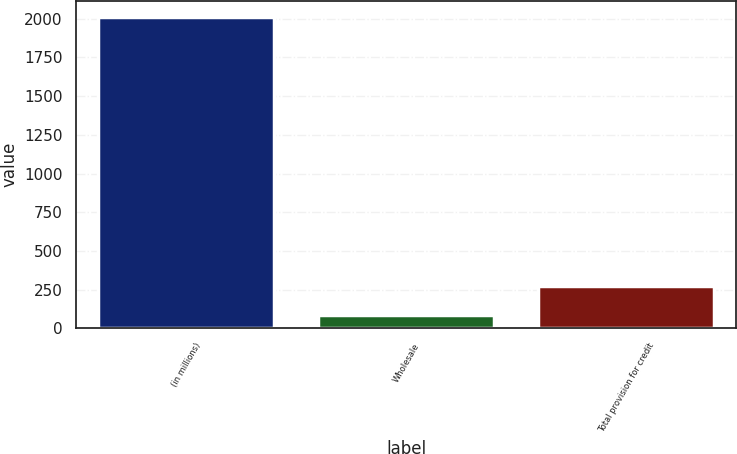Convert chart. <chart><loc_0><loc_0><loc_500><loc_500><bar_chart><fcel>(in millions)<fcel>Wholesale<fcel>Total provision for credit<nl><fcel>2013<fcel>83<fcel>276<nl></chart> 